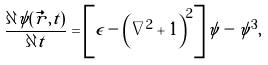<formula> <loc_0><loc_0><loc_500><loc_500>\frac { \partial \psi ( \vec { r } , t ) } { \partial t } = \left [ \epsilon - \left ( \nabla ^ { 2 } + 1 \right ) ^ { 2 } \right ] \psi - \psi ^ { 3 } ,</formula> 